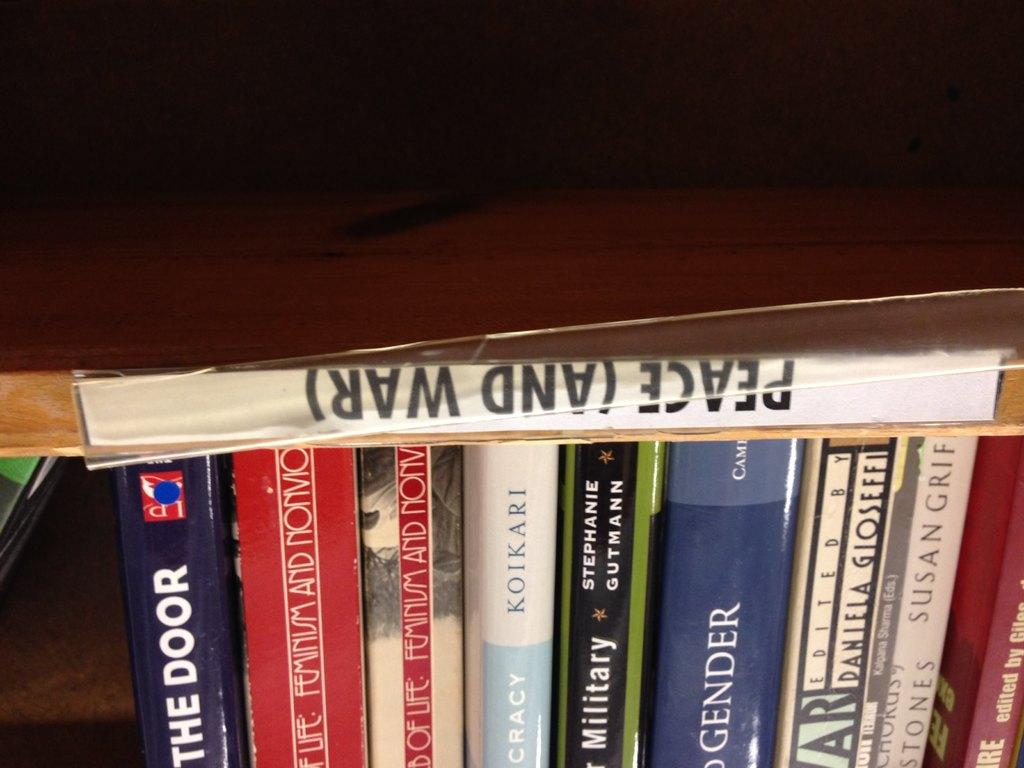<image>
Give a short and clear explanation of the subsequent image. A collection of book with a title of Peace (and War) on top. 